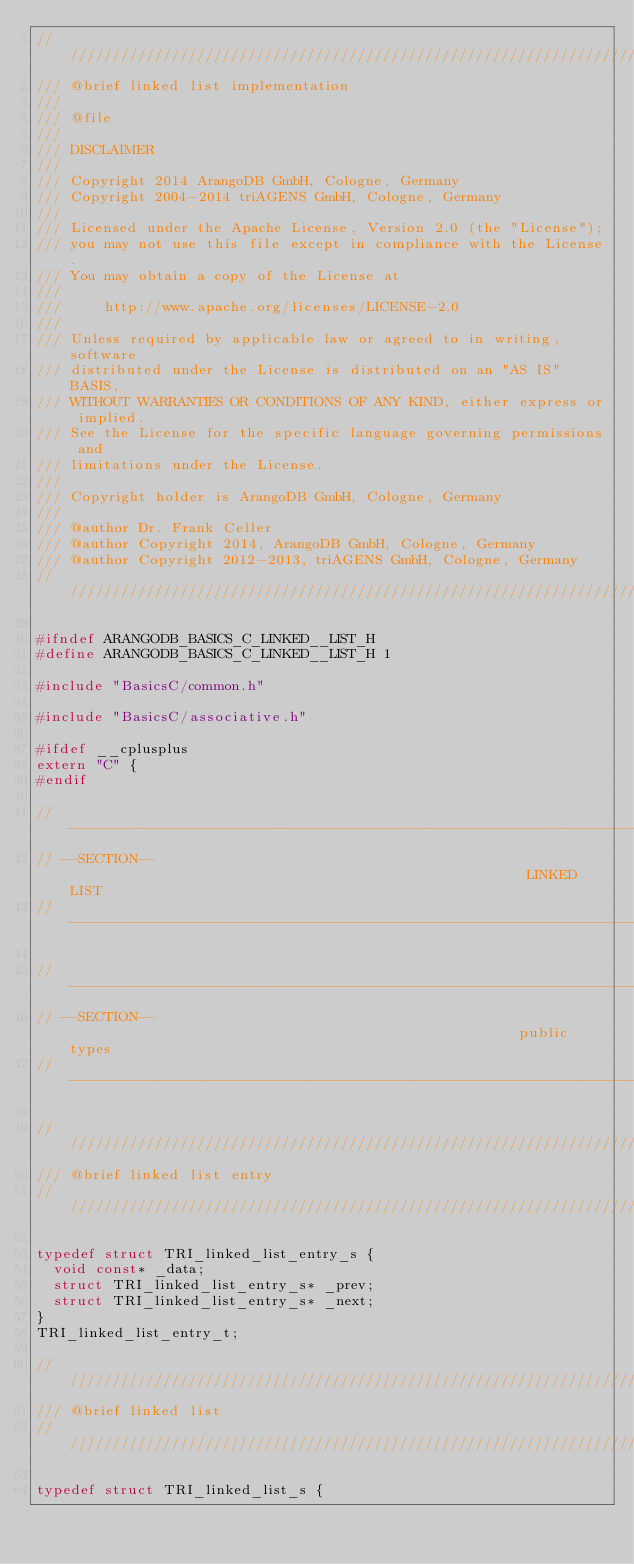Convert code to text. <code><loc_0><loc_0><loc_500><loc_500><_C_>////////////////////////////////////////////////////////////////////////////////
/// @brief linked list implementation
///
/// @file
///
/// DISCLAIMER
///
/// Copyright 2014 ArangoDB GmbH, Cologne, Germany
/// Copyright 2004-2014 triAGENS GmbH, Cologne, Germany
///
/// Licensed under the Apache License, Version 2.0 (the "License");
/// you may not use this file except in compliance with the License.
/// You may obtain a copy of the License at
///
///     http://www.apache.org/licenses/LICENSE-2.0
///
/// Unless required by applicable law or agreed to in writing, software
/// distributed under the License is distributed on an "AS IS" BASIS,
/// WITHOUT WARRANTIES OR CONDITIONS OF ANY KIND, either express or implied.
/// See the License for the specific language governing permissions and
/// limitations under the License.
///
/// Copyright holder is ArangoDB GmbH, Cologne, Germany
///
/// @author Dr. Frank Celler
/// @author Copyright 2014, ArangoDB GmbH, Cologne, Germany
/// @author Copyright 2012-2013, triAGENS GmbH, Cologne, Germany
////////////////////////////////////////////////////////////////////////////////

#ifndef ARANGODB_BASICS_C_LINKED__LIST_H
#define ARANGODB_BASICS_C_LINKED__LIST_H 1

#include "BasicsC/common.h"

#include "BasicsC/associative.h"

#ifdef __cplusplus
extern "C" {
#endif

// -----------------------------------------------------------------------------
// --SECTION--                                                       LINKED LIST
// -----------------------------------------------------------------------------

// -----------------------------------------------------------------------------
// --SECTION--                                                      public types
// -----------------------------------------------------------------------------

////////////////////////////////////////////////////////////////////////////////
/// @brief linked list entry
////////////////////////////////////////////////////////////////////////////////

typedef struct TRI_linked_list_entry_s {
  void const* _data;
  struct TRI_linked_list_entry_s* _prev;
  struct TRI_linked_list_entry_s* _next;
}
TRI_linked_list_entry_t;

////////////////////////////////////////////////////////////////////////////////
/// @brief linked list
////////////////////////////////////////////////////////////////////////////////

typedef struct TRI_linked_list_s {</code> 